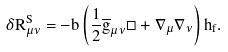<formula> <loc_0><loc_0><loc_500><loc_500>\delta R _ { \mu \nu } ^ { S } = - b \left ( \frac { 1 } { 2 } \overline { g } _ { \mu \nu } \square + \nabla _ { \mu } \nabla _ { \nu } \right ) h _ { f } .</formula> 